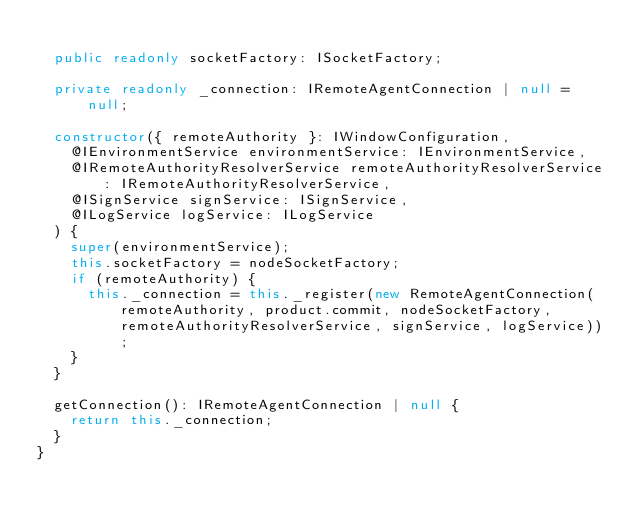<code> <loc_0><loc_0><loc_500><loc_500><_TypeScript_>
	public readonly socketFactory: ISocketFactory;

	private readonly _connection: IRemoteAgentConnection | null = null;

	constructor({ remoteAuthority }: IWindowConfiguration,
		@IEnvironmentService environmentService: IEnvironmentService,
		@IRemoteAuthorityResolverService remoteAuthorityResolverService: IRemoteAuthorityResolverService,
		@ISignService signService: ISignService,
		@ILogService logService: ILogService
	) {
		super(environmentService);
		this.socketFactory = nodeSocketFactory;
		if (remoteAuthority) {
			this._connection = this._register(new RemoteAgentConnection(remoteAuthority, product.commit, nodeSocketFactory, remoteAuthorityResolverService, signService, logService));
		}
	}

	getConnection(): IRemoteAgentConnection | null {
		return this._connection;
	}
}
</code> 